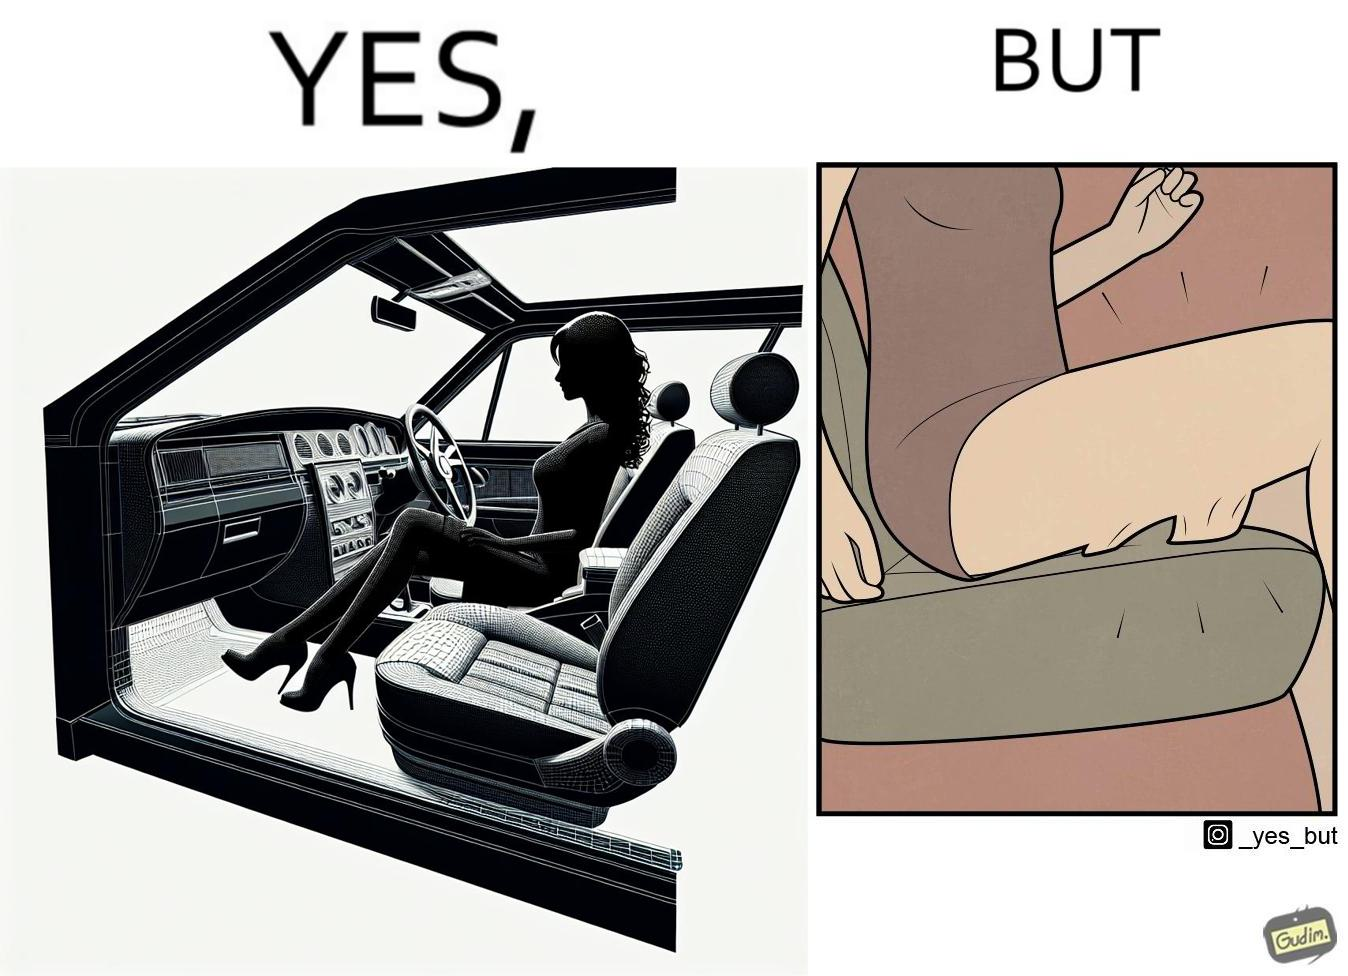Why is this image considered satirical? The image is ironic, because the woman is wearing a short dress to look stylish but she had to face inconvenience while travelling in car due to her short dress only. 